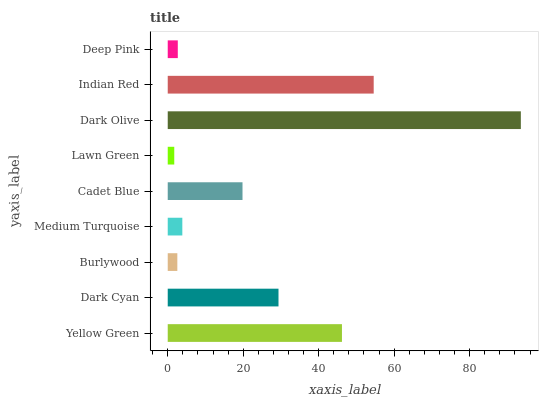Is Lawn Green the minimum?
Answer yes or no. Yes. Is Dark Olive the maximum?
Answer yes or no. Yes. Is Dark Cyan the minimum?
Answer yes or no. No. Is Dark Cyan the maximum?
Answer yes or no. No. Is Yellow Green greater than Dark Cyan?
Answer yes or no. Yes. Is Dark Cyan less than Yellow Green?
Answer yes or no. Yes. Is Dark Cyan greater than Yellow Green?
Answer yes or no. No. Is Yellow Green less than Dark Cyan?
Answer yes or no. No. Is Cadet Blue the high median?
Answer yes or no. Yes. Is Cadet Blue the low median?
Answer yes or no. Yes. Is Indian Red the high median?
Answer yes or no. No. Is Medium Turquoise the low median?
Answer yes or no. No. 